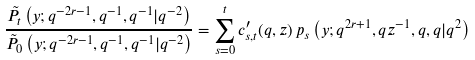<formula> <loc_0><loc_0><loc_500><loc_500>\frac { \tilde { P } _ { t } \left ( y ; q ^ { - 2 r - 1 } , q ^ { - 1 } , q ^ { - 1 } | q ^ { - 2 } \right ) } { \tilde { P } _ { 0 } \left ( y ; q ^ { - 2 r - 1 } , q ^ { - 1 } , q ^ { - 1 } | q ^ { - 2 } \right ) } = \sum _ { s = 0 } ^ { t } c ^ { \prime } _ { s , t } ( q , z ) \, p _ { s } \left ( y ; q ^ { 2 r + 1 } , q z ^ { - 1 } , q , q | q ^ { 2 } \right )</formula> 